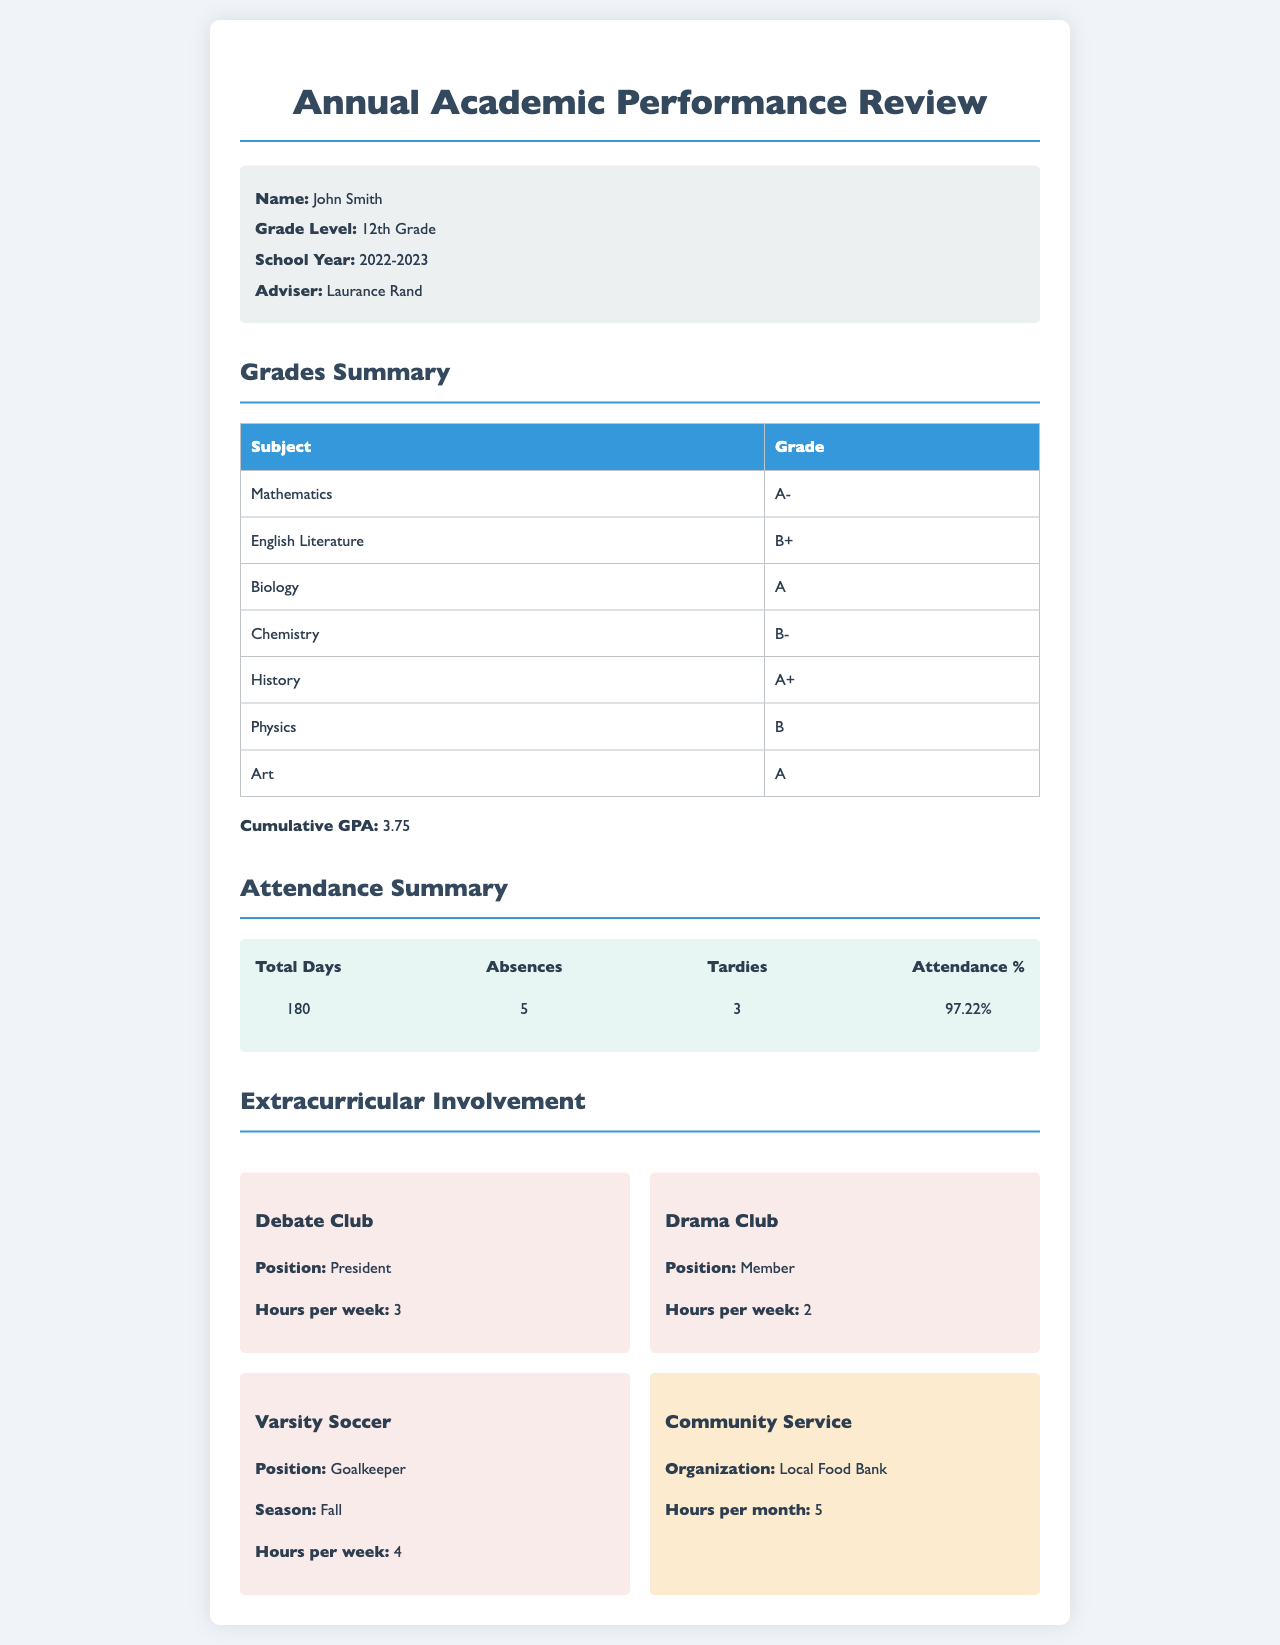What is the name of the student? The name of the student is provided in the student info section of the document.
Answer: John Smith What is the cumulative GPA? The cumulative GPA is presented under the Grades Summary section.
Answer: 3.75 How many subjects received an A grade? The document lists the grades for each subject, allowing the counting of A grades to answer this question.
Answer: 4 What is the total number of absences? The number of absences is provided in the Attendance Summary section.
Answer: 5 What position does John Smith hold in the Debate Club? The position John Smith holds is mentioned in the Extracurricular Involvement section.
Answer: President What percentage of attendance did John Smith achieve? The attendance percentage is listed in the Attendance Summary section of the document.
Answer: 97.22% How many hours per week does John Smith dedicate to Varsity Soccer? The document specifies the hours per week dedicated to each extracurricular activity, including Varsity Soccer.
Answer: 4 What organization is associated with the community service? The organization for the community service activity is noted in the Extracurricular Involvement section.
Answer: Local Food Bank 